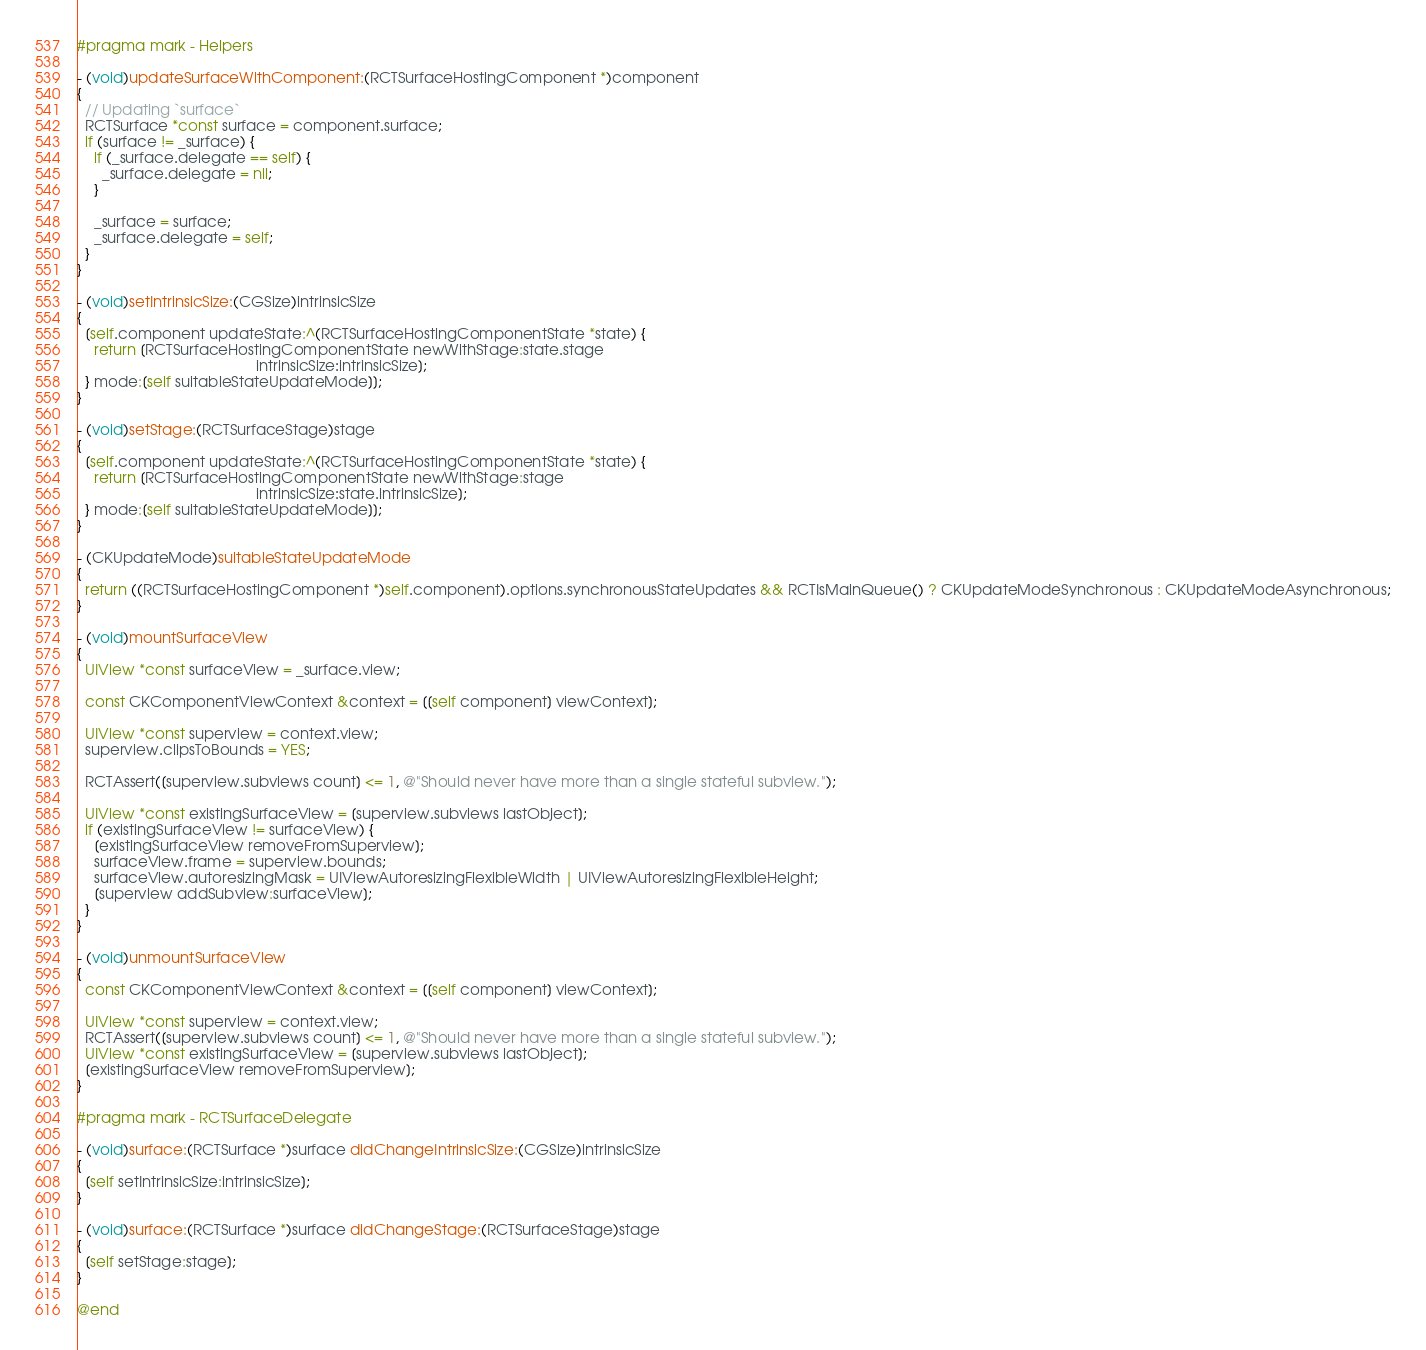Convert code to text. <code><loc_0><loc_0><loc_500><loc_500><_ObjectiveC_>#pragma mark - Helpers

- (void)updateSurfaceWithComponent:(RCTSurfaceHostingComponent *)component
{
  // Updating `surface`
  RCTSurface *const surface = component.surface;
  if (surface != _surface) {
    if (_surface.delegate == self) {
      _surface.delegate = nil;
    }

    _surface = surface;
    _surface.delegate = self;
  }
}

- (void)setIntrinsicSize:(CGSize)intrinsicSize
{
  [self.component updateState:^(RCTSurfaceHostingComponentState *state) {
    return [RCTSurfaceHostingComponentState newWithStage:state.stage
                                           intrinsicSize:intrinsicSize];
  } mode:[self suitableStateUpdateMode]];
}

- (void)setStage:(RCTSurfaceStage)stage
{
  [self.component updateState:^(RCTSurfaceHostingComponentState *state) {
    return [RCTSurfaceHostingComponentState newWithStage:stage
                                           intrinsicSize:state.intrinsicSize];
  } mode:[self suitableStateUpdateMode]];
}

- (CKUpdateMode)suitableStateUpdateMode
{
  return ((RCTSurfaceHostingComponent *)self.component).options.synchronousStateUpdates && RCTIsMainQueue() ? CKUpdateModeSynchronous : CKUpdateModeAsynchronous;
}

- (void)mountSurfaceView
{
  UIView *const surfaceView = _surface.view;

  const CKComponentViewContext &context = [[self component] viewContext];

  UIView *const superview = context.view;
  superview.clipsToBounds = YES;

  RCTAssert([superview.subviews count] <= 1, @"Should never have more than a single stateful subview.");

  UIView *const existingSurfaceView = [superview.subviews lastObject];
  if (existingSurfaceView != surfaceView) {
    [existingSurfaceView removeFromSuperview];
    surfaceView.frame = superview.bounds;
    surfaceView.autoresizingMask = UIViewAutoresizingFlexibleWidth | UIViewAutoresizingFlexibleHeight;
    [superview addSubview:surfaceView];
  }
}

- (void)unmountSurfaceView
{
  const CKComponentViewContext &context = [[self component] viewContext];

  UIView *const superview = context.view;
  RCTAssert([superview.subviews count] <= 1, @"Should never have more than a single stateful subview.");
  UIView *const existingSurfaceView = [superview.subviews lastObject];
  [existingSurfaceView removeFromSuperview];
}

#pragma mark - RCTSurfaceDelegate

- (void)surface:(RCTSurface *)surface didChangeIntrinsicSize:(CGSize)intrinsicSize
{
  [self setIntrinsicSize:intrinsicSize];
}

- (void)surface:(RCTSurface *)surface didChangeStage:(RCTSurfaceStage)stage
{
  [self setStage:stage];
}

@end
</code> 